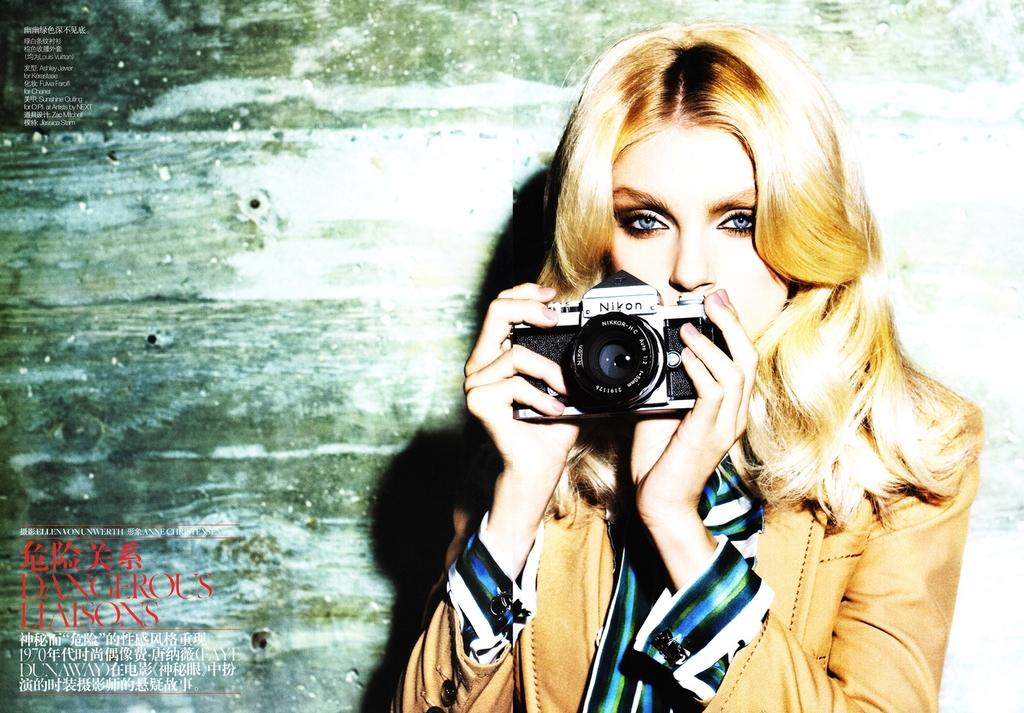Who is the main subject in the image? There is a woman in the image. What is the woman wearing? The woman is wearing a jacket. What is the woman holding in the image? The woman is holding a camera. What can be seen in the background of the image? There is a wall and a poster in the background of the image. What type of cherry is the woman eating in the image? There is no cherry present in the image, and the woman is holding a camera, not eating anything. 